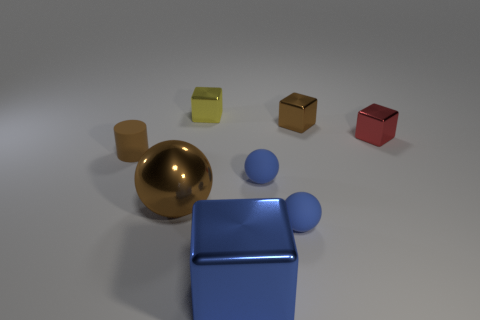Subtract all matte spheres. How many spheres are left? 1 Add 1 big yellow shiny blocks. How many objects exist? 9 Subtract all red cylinders. How many blue spheres are left? 2 Subtract all brown cubes. How many cubes are left? 3 Subtract 0 yellow spheres. How many objects are left? 8 Subtract all cylinders. How many objects are left? 7 Subtract 1 spheres. How many spheres are left? 2 Subtract all gray balls. Subtract all yellow blocks. How many balls are left? 3 Subtract all yellow shiny blocks. Subtract all small brown metal objects. How many objects are left? 6 Add 2 large blue things. How many large blue things are left? 3 